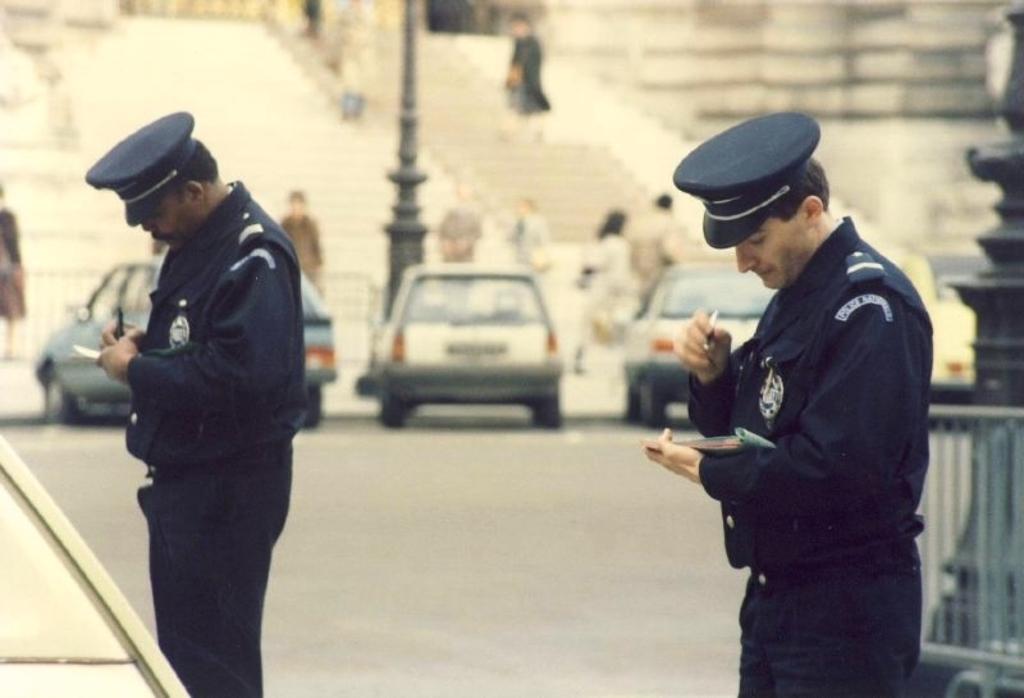In one or two sentences, can you explain what this image depicts? In this image, there are a few people and vehicles. We can see the ground. We can see some poles and an object on the right. We can see some stairs and the wall. 